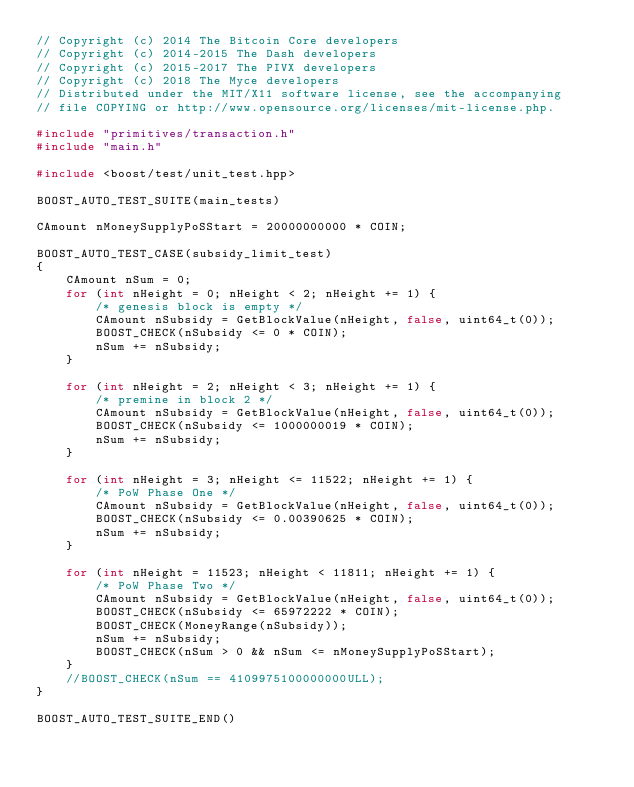Convert code to text. <code><loc_0><loc_0><loc_500><loc_500><_C++_>// Copyright (c) 2014 The Bitcoin Core developers
// Copyright (c) 2014-2015 The Dash developers
// Copyright (c) 2015-2017 The PIVX developers
// Copyright (c) 2018 The Myce developers
// Distributed under the MIT/X11 software license, see the accompanying
// file COPYING or http://www.opensource.org/licenses/mit-license.php.

#include "primitives/transaction.h"
#include "main.h"

#include <boost/test/unit_test.hpp>

BOOST_AUTO_TEST_SUITE(main_tests)

CAmount nMoneySupplyPoSStart = 20000000000 * COIN;

BOOST_AUTO_TEST_CASE(subsidy_limit_test)
{
    CAmount nSum = 0;
    for (int nHeight = 0; nHeight < 2; nHeight += 1) {
        /* genesis block is empty */
        CAmount nSubsidy = GetBlockValue(nHeight, false, uint64_t(0));
        BOOST_CHECK(nSubsidy <= 0 * COIN);
        nSum += nSubsidy;
    }

    for (int nHeight = 2; nHeight < 3; nHeight += 1) {
        /* premine in block 2 */
        CAmount nSubsidy = GetBlockValue(nHeight, false, uint64_t(0));
        BOOST_CHECK(nSubsidy <= 1000000019 * COIN);
        nSum += nSubsidy;
    }

    for (int nHeight = 3; nHeight <= 11522; nHeight += 1) {
        /* PoW Phase One */
        CAmount nSubsidy = GetBlockValue(nHeight, false, uint64_t(0));
        BOOST_CHECK(nSubsidy <= 0.00390625 * COIN);
        nSum += nSubsidy;
    }

    for (int nHeight = 11523; nHeight < 11811; nHeight += 1) {
        /* PoW Phase Two */
        CAmount nSubsidy = GetBlockValue(nHeight, false, uint64_t(0));
        BOOST_CHECK(nSubsidy <= 65972222 * COIN);
        BOOST_CHECK(MoneyRange(nSubsidy));
        nSum += nSubsidy;
        BOOST_CHECK(nSum > 0 && nSum <= nMoneySupplyPoSStart);
    }
    //BOOST_CHECK(nSum == 4109975100000000ULL);
}

BOOST_AUTO_TEST_SUITE_END()
</code> 